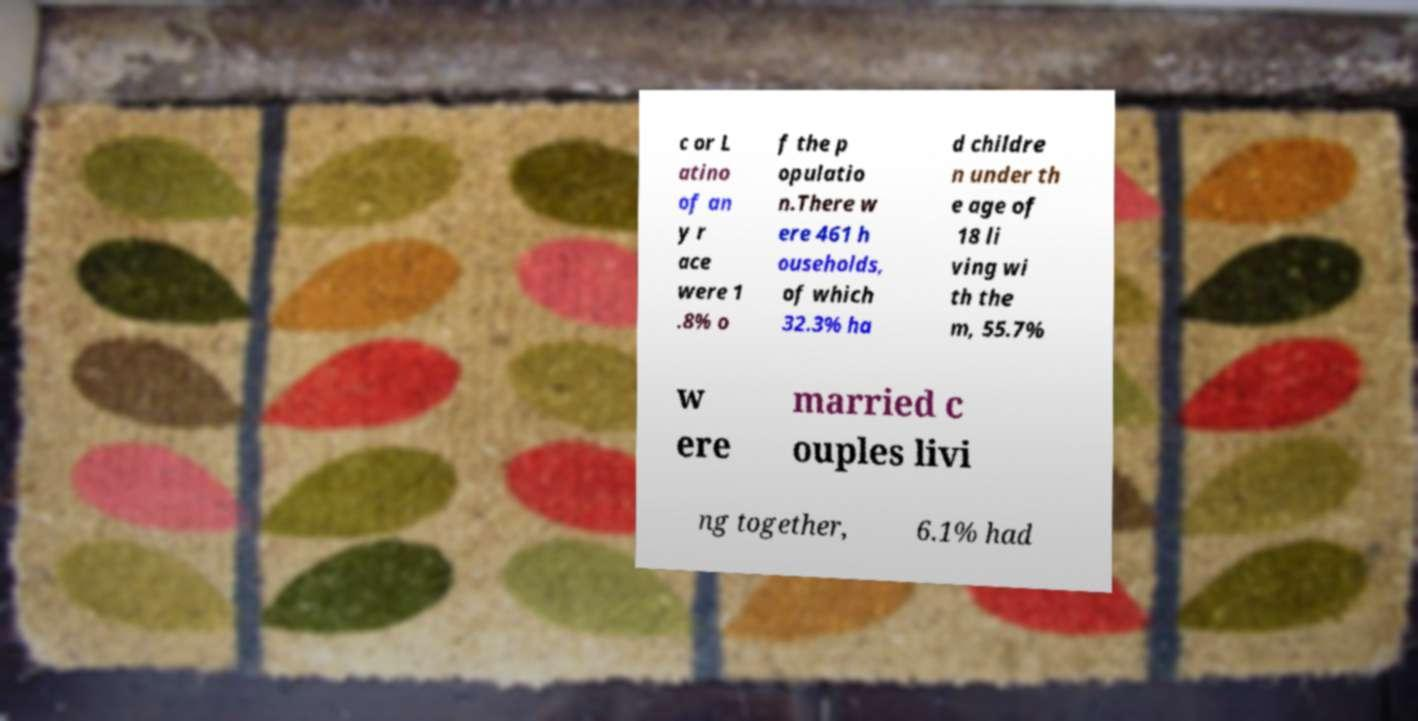Can you accurately transcribe the text from the provided image for me? c or L atino of an y r ace were 1 .8% o f the p opulatio n.There w ere 461 h ouseholds, of which 32.3% ha d childre n under th e age of 18 li ving wi th the m, 55.7% w ere married c ouples livi ng together, 6.1% had 